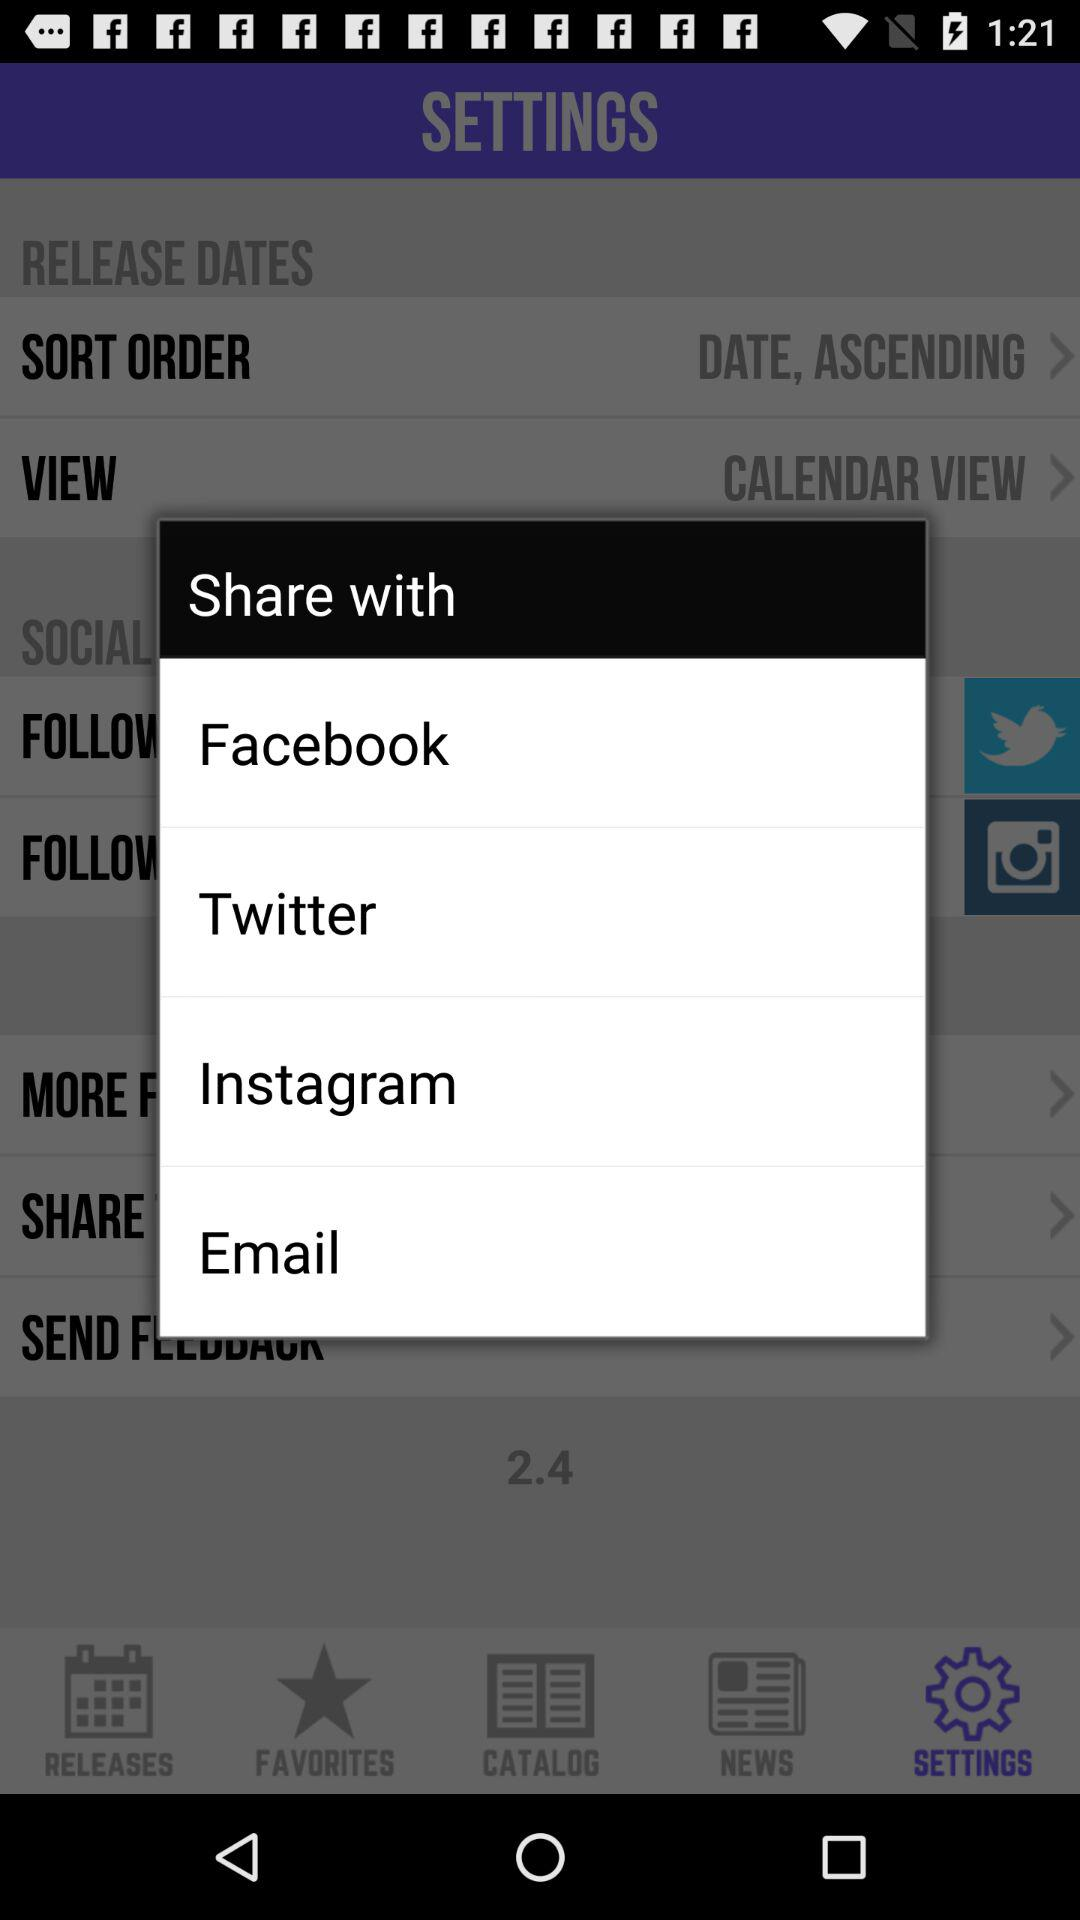Which options are given to share with? The given options are "Facebook", "Twitter", "Instagram" and "Email". 